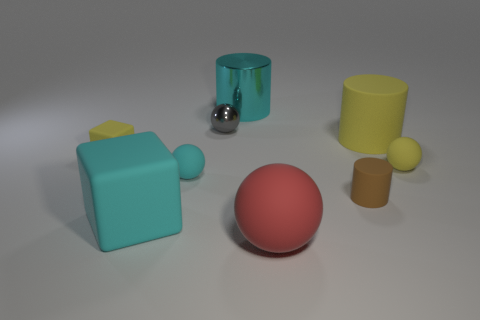The cyan metallic thing has what shape?
Your answer should be compact. Cylinder. How many big cylinders are right of the rubber ball that is on the right side of the matte cylinder that is behind the small yellow ball?
Give a very brief answer. 0. What number of other objects are the same material as the cyan cylinder?
Your answer should be very brief. 1. What material is the other cyan ball that is the same size as the shiny ball?
Offer a terse response. Rubber. Does the big cylinder behind the gray sphere have the same color as the large matte thing in front of the big cyan matte block?
Make the answer very short. No. Is there a big yellow rubber thing of the same shape as the gray metal thing?
Offer a very short reply. No. The brown thing that is the same size as the cyan rubber sphere is what shape?
Ensure brevity in your answer.  Cylinder. What number of tiny balls have the same color as the big cube?
Provide a succinct answer. 1. There is a ball that is right of the red rubber ball; what is its size?
Provide a short and direct response. Small. What number of gray balls are the same size as the cyan shiny thing?
Ensure brevity in your answer.  0. 